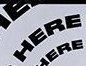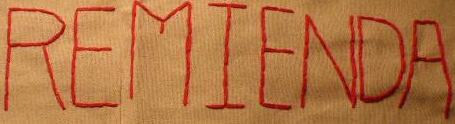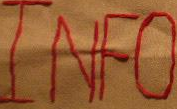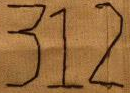Identify the words shown in these images in order, separated by a semicolon. HERE; REMIENDA; INFO; 312 